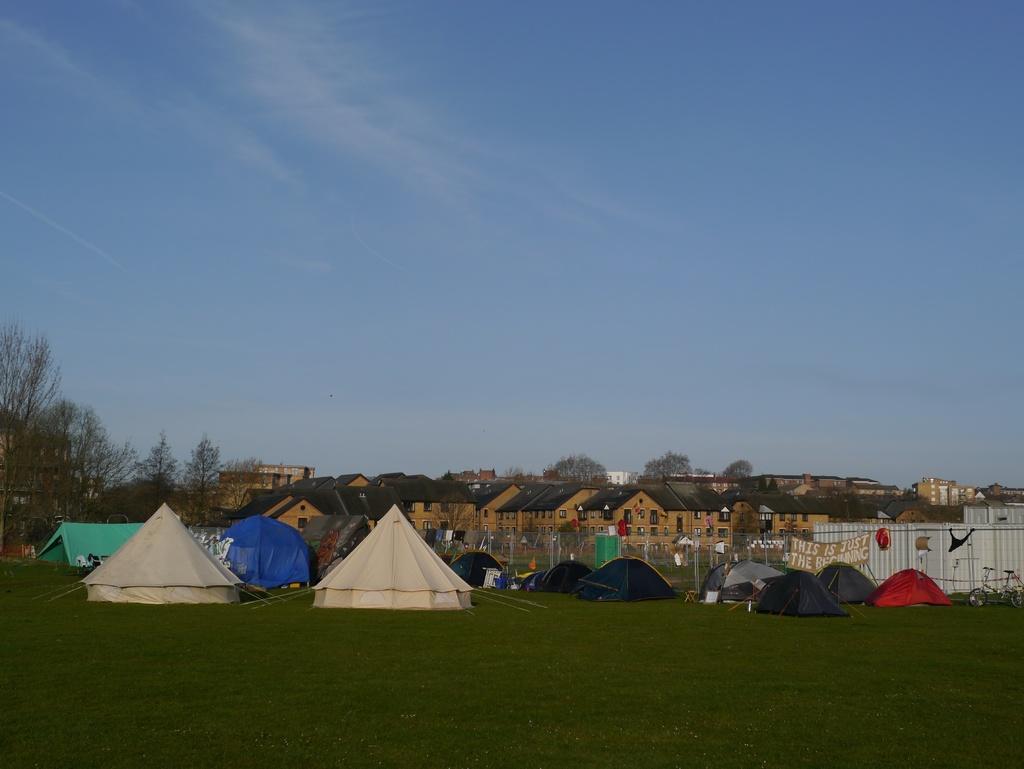In one or two sentences, can you explain what this image depicts? In this image we can see a few tents and buildings, there are some trees, poles, grass, bicycle and a poster with some text, in the background we can see the sky with clouds. 